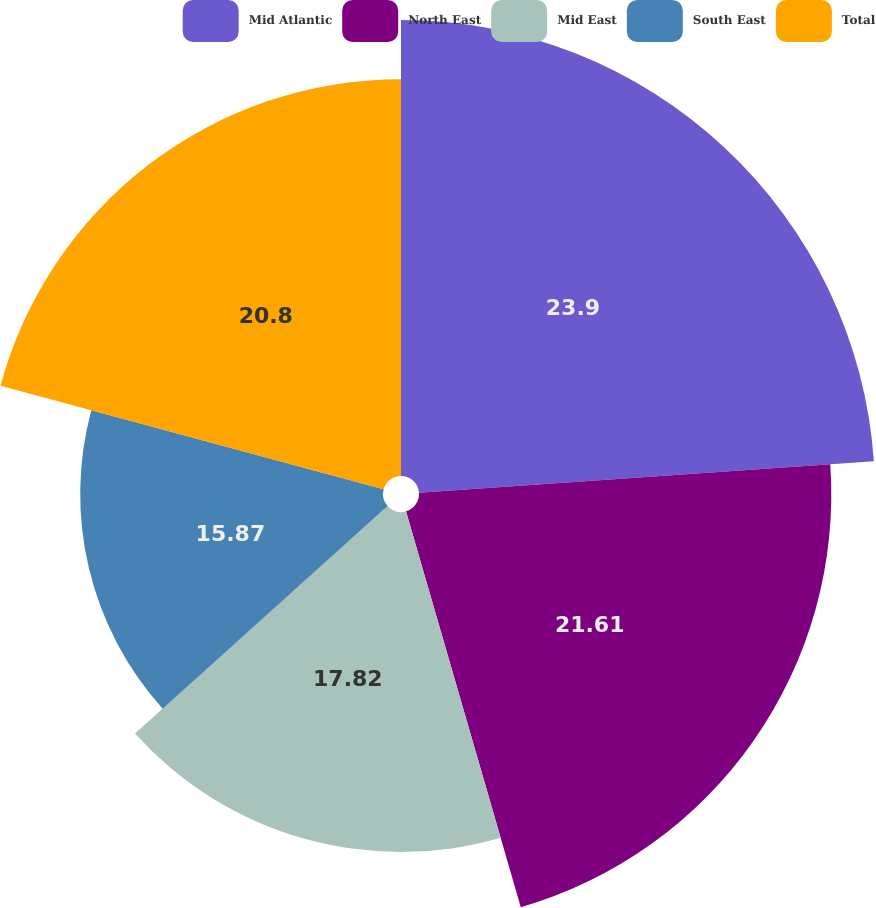<chart> <loc_0><loc_0><loc_500><loc_500><pie_chart><fcel>Mid Atlantic<fcel>North East<fcel>Mid East<fcel>South East<fcel>Total<nl><fcel>23.9%<fcel>21.61%<fcel>17.82%<fcel>15.87%<fcel>20.8%<nl></chart> 